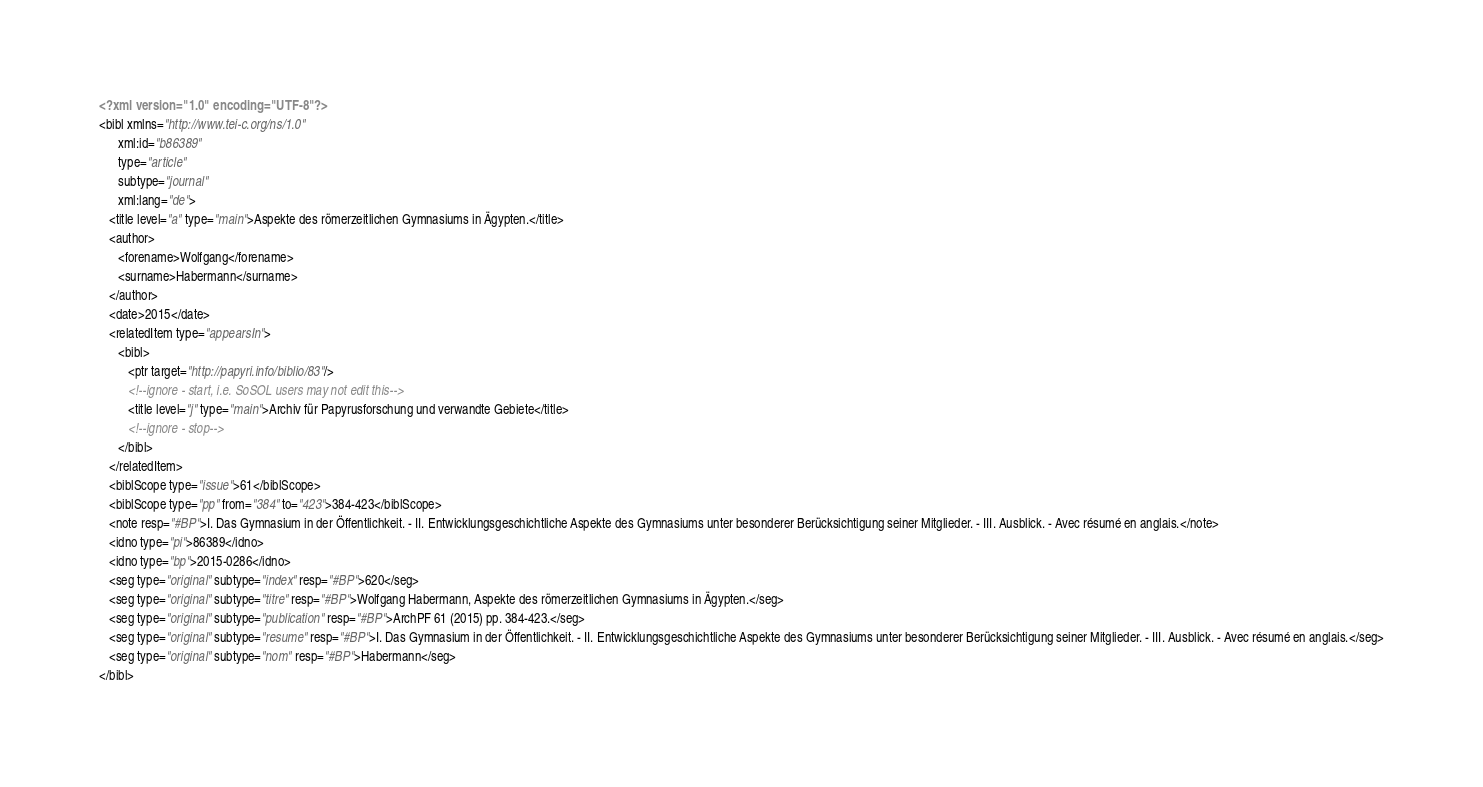Convert code to text. <code><loc_0><loc_0><loc_500><loc_500><_XML_><?xml version="1.0" encoding="UTF-8"?>
<bibl xmlns="http://www.tei-c.org/ns/1.0"
      xml:id="b86389"
      type="article"
      subtype="journal"
      xml:lang="de">
   <title level="a" type="main">Aspekte des römerzeitlichen Gymnasiums in Ägypten.</title>
   <author>
      <forename>Wolfgang</forename>
      <surname>Habermann</surname>
   </author>
   <date>2015</date>
   <relatedItem type="appearsIn">
      <bibl>
         <ptr target="http://papyri.info/biblio/83"/>
         <!--ignore - start, i.e. SoSOL users may not edit this-->
         <title level="j" type="main">Archiv für Papyrusforschung und verwandte Gebiete</title>
         <!--ignore - stop-->
      </bibl>
   </relatedItem>
   <biblScope type="issue">61</biblScope>
   <biblScope type="pp" from="384" to="423">384-423</biblScope>
   <note resp="#BP">I. Das Gymnasium in der Öffentlichkeit. - II. Entwicklungsgeschichtliche Aspekte des Gymnasiums unter besonderer Berücksichtigung seiner Mitglieder. - III. Ausblick. - Avec résumé en anglais.</note>
   <idno type="pi">86389</idno>
   <idno type="bp">2015-0286</idno>
   <seg type="original" subtype="index" resp="#BP">620</seg>
   <seg type="original" subtype="titre" resp="#BP">Wolfgang Habermann, Aspekte des römerzeitlichen Gymnasiums in Ägypten.</seg>
   <seg type="original" subtype="publication" resp="#BP">ArchPF 61 (2015) pp. 384-423.</seg>
   <seg type="original" subtype="resume" resp="#BP">I. Das Gymnasium in der Öffentlichkeit. - II. Entwicklungsgeschichtliche Aspekte des Gymnasiums unter besonderer Berücksichtigung seiner Mitglieder. - III. Ausblick. - Avec résumé en anglais.</seg>
   <seg type="original" subtype="nom" resp="#BP">Habermann</seg>
</bibl>
</code> 